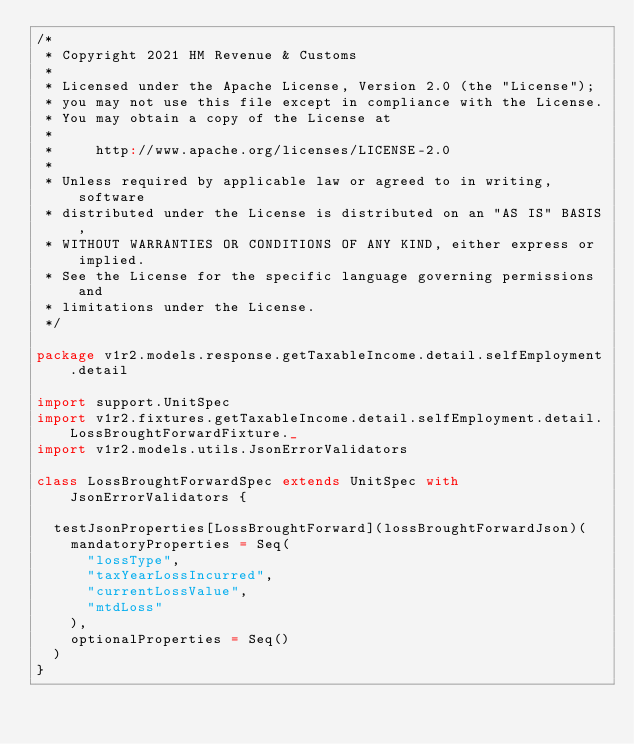Convert code to text. <code><loc_0><loc_0><loc_500><loc_500><_Scala_>/*
 * Copyright 2021 HM Revenue & Customs
 *
 * Licensed under the Apache License, Version 2.0 (the "License");
 * you may not use this file except in compliance with the License.
 * You may obtain a copy of the License at
 *
 *     http://www.apache.org/licenses/LICENSE-2.0
 *
 * Unless required by applicable law or agreed to in writing, software
 * distributed under the License is distributed on an "AS IS" BASIS,
 * WITHOUT WARRANTIES OR CONDITIONS OF ANY KIND, either express or implied.
 * See the License for the specific language governing permissions and
 * limitations under the License.
 */

package v1r2.models.response.getTaxableIncome.detail.selfEmployment.detail

import support.UnitSpec
import v1r2.fixtures.getTaxableIncome.detail.selfEmployment.detail.LossBroughtForwardFixture._
import v1r2.models.utils.JsonErrorValidators

class LossBroughtForwardSpec extends UnitSpec with JsonErrorValidators {

  testJsonProperties[LossBroughtForward](lossBroughtForwardJson)(
    mandatoryProperties = Seq(
      "lossType",
      "taxYearLossIncurred",
      "currentLossValue",
      "mtdLoss"
    ),
    optionalProperties = Seq()
  )
}</code> 